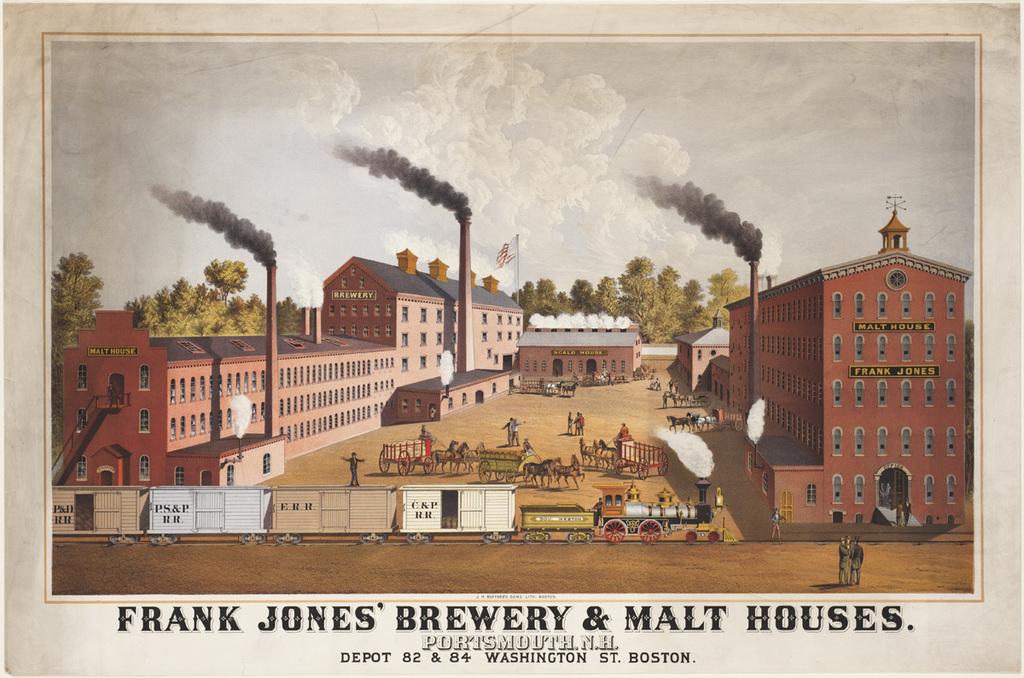This building was named after who?
Keep it short and to the point. Frank jones. What town is this painting in?
Ensure brevity in your answer.  Portsmouth. 